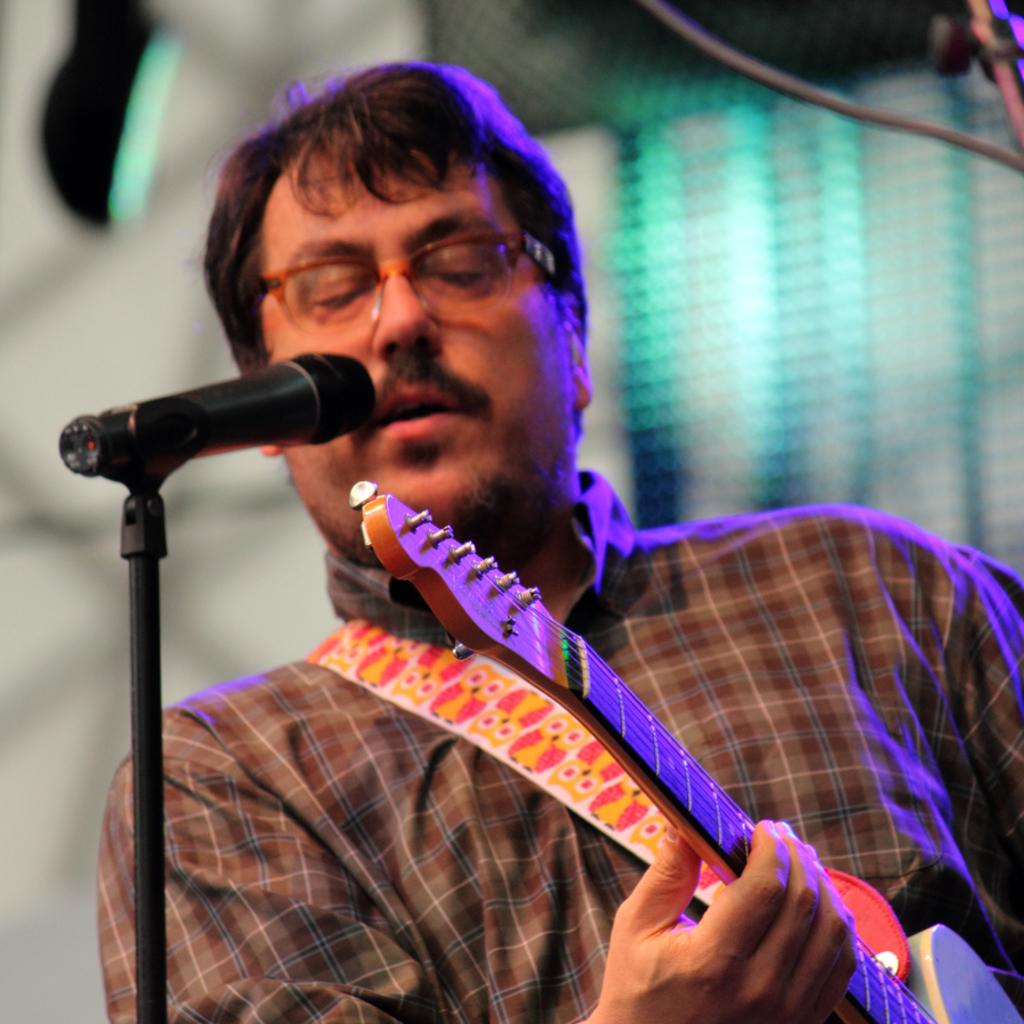What is the man in the image holding? The man is holding a guitar in the image. What object is in front of the man? There is a microphone in front of the man. What can be seen in the background of the image? There is a wall and a light in the background of the image. What type of prose is the man reciting into the microphone in the image? There is no indication in the image that the man is reciting any prose, as he is holding a guitar and there is a microphone in front of him. 